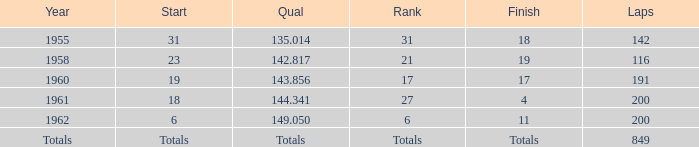Can you parse all the data within this table? {'header': ['Year', 'Start', 'Qual', 'Rank', 'Finish', 'Laps'], 'rows': [['1955', '31', '135.014', '31', '18', '142'], ['1958', '23', '142.817', '21', '19', '116'], ['1960', '19', '143.856', '17', '17', '191'], ['1961', '18', '144.341', '27', '4', '200'], ['1962', '6', '149.050', '6', '11', '200'], ['Totals', 'Totals', 'Totals', 'Totals', 'Totals', '849']]} Which year concludes with the digits 19? 1958.0. 